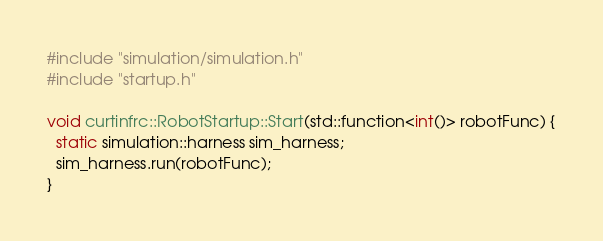Convert code to text. <code><loc_0><loc_0><loc_500><loc_500><_C++_>#include "simulation/simulation.h"
#include "startup.h"

void curtinfrc::RobotStartup::Start(std::function<int()> robotFunc) {
  static simulation::harness sim_harness;
  sim_harness.run(robotFunc);
}
</code> 